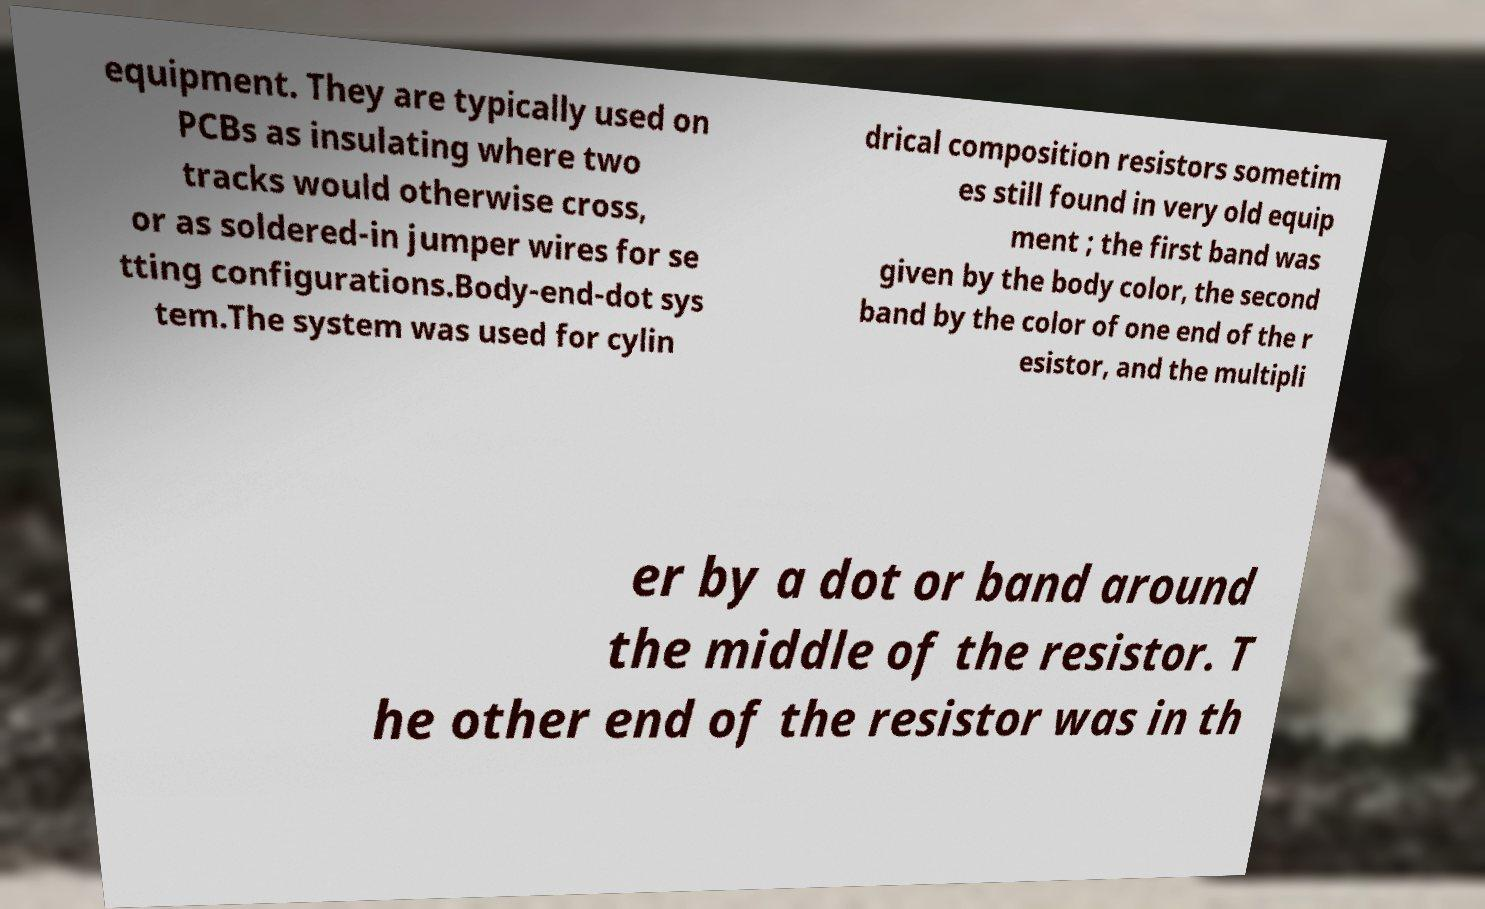Can you read and provide the text displayed in the image?This photo seems to have some interesting text. Can you extract and type it out for me? equipment. They are typically used on PCBs as insulating where two tracks would otherwise cross, or as soldered-in jumper wires for se tting configurations.Body-end-dot sys tem.The system was used for cylin drical composition resistors sometim es still found in very old equip ment ; the first band was given by the body color, the second band by the color of one end of the r esistor, and the multipli er by a dot or band around the middle of the resistor. T he other end of the resistor was in th 